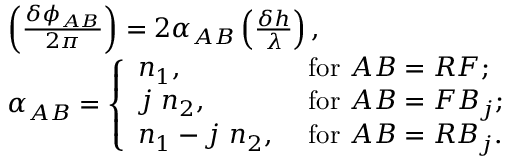Convert formula to latex. <formula><loc_0><loc_0><loc_500><loc_500>\begin{array} { r l } & { \left ( \frac { \delta \phi _ { A B } } { 2 \pi } \right ) = 2 \alpha _ { A B } \left ( \frac { \delta h } { \lambda } \right ) , } \\ & { \alpha _ { A B } = \left \{ \begin{array} { l l } { n _ { 1 } , } & { f o r A B = R F ; } \\ { j n _ { 2 } , } & { f o r A B = F B _ { j } ; } \\ { n _ { 1 } - j n _ { 2 } , } & { f o r A B = R B _ { j } . } \end{array} } \end{array}</formula> 